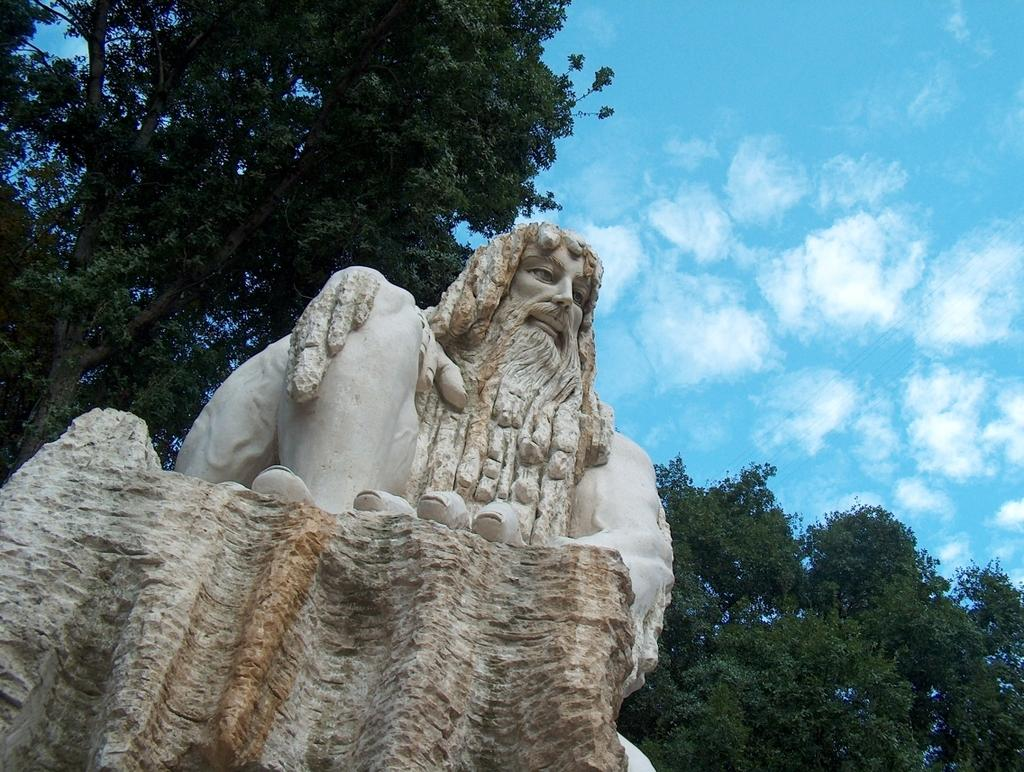What is the main subject of the image? There is a statue of a person in the image. Where is the statue located? The statue is on a rock. What can be seen in the background of the image? There are trees and the sky visible in the background of the image. What type of connection does the statue have with the trees in the background? There is no direct connection between the statue and the trees in the image; they are separate elements in the scene. 